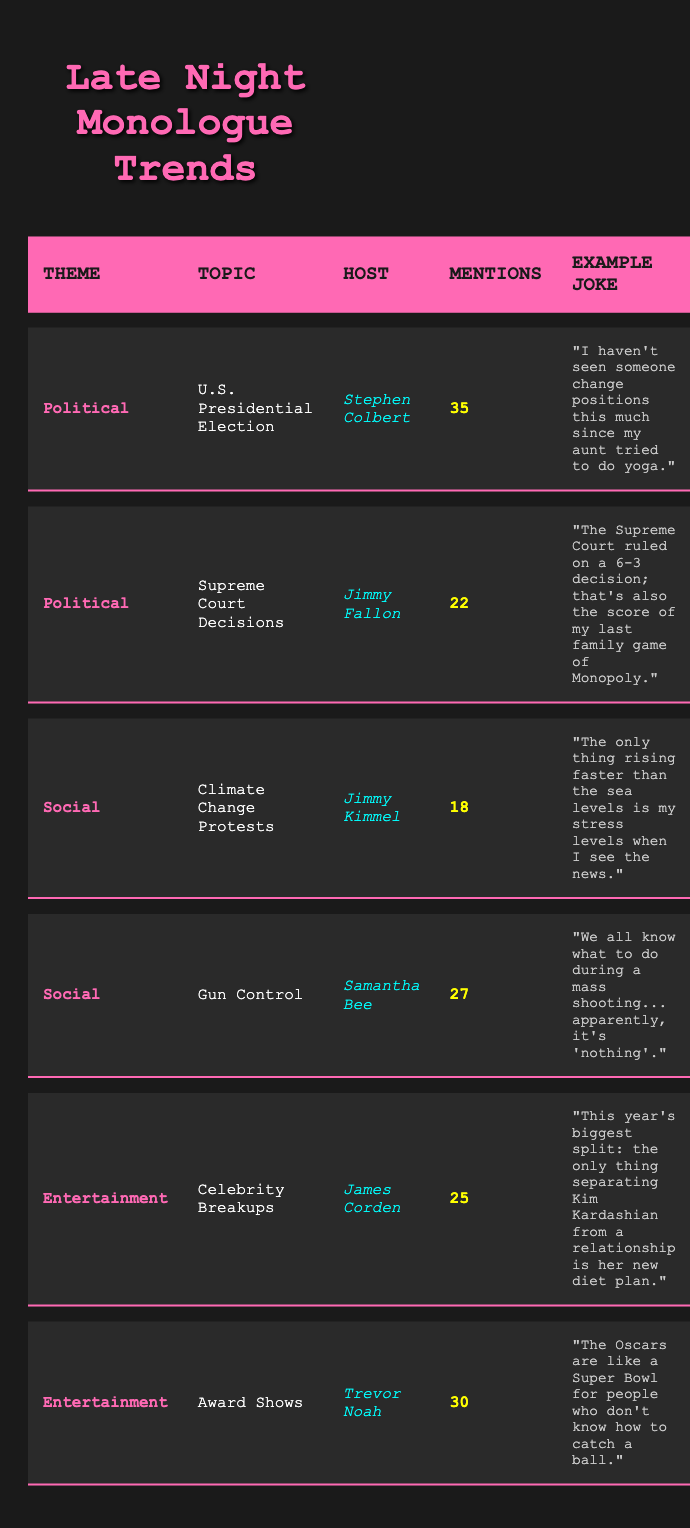What is the theme with the highest mention count? By examining the table, we see that "Political" is the theme with the highest total mentions, as it has a 35 mentions for the U.S. Presidential Election by Stephen Colbert.
Answer: Political Which host appears most frequently in the data? The data lists different hosts for various topics. Stephen Colbert appears once, Jimmy Fallon appears once, Jimmy Kimmel appears once, Samantha Bee appears once, James Corden appears once, and Trevor Noah appears once. There is no host who appears more than once.
Answer: No host appears more than once What is the combined mention count for Social themes? To find the combined mention count for Social themes, we need to add the mention counts for Climate Change Protests (18) and Gun Control (27). So we calculate 18 + 27 = 45.
Answer: 45 Is there a theme with exactly 30 mentions? Looking through the table, the only theme that precisely has 30 mentions is within the Entertainment category for Award Shows by Trevor Noah.
Answer: Yes What theme has the least number of mentions and what is that count? In the table, the theme with the least number of mentions is "Social" with "Climate Change Protests," which has 18 mentions.
Answer: Social, 18 Which topic had the maximum mentions and who hosted it? The topic with the most mentions is the "U.S. Presidential Election," hosted by Stephen Colbert, with a mention count of 35.
Answer: U.S. Presidential Election, Stephen Colbert What is the average mention count for the Entertainment themes? The mention counts for Entertainment are 25 (Celebrity Breakups) and 30 (Award Shows). We sum these counts: 25 + 30 = 55. To find the average, we divide by the number of topics, which is 2. Therefore, the average is 55 / 2 = 27.5.
Answer: 27.5 How many mentions of Gun Control were made by any host? The table lists Gun Control with 27 mentions made by Samantha Bee. Thus, the total mentions are simply 27.
Answer: 27 What was the example joke related to climate change protests? The example joke provided in the table for Climate Change Protests is "The only thing rising faster than the sea levels is my stress levels when I see the news."
Answer: The only thing rising faster than the sea levels is my stress levels when I see the news 